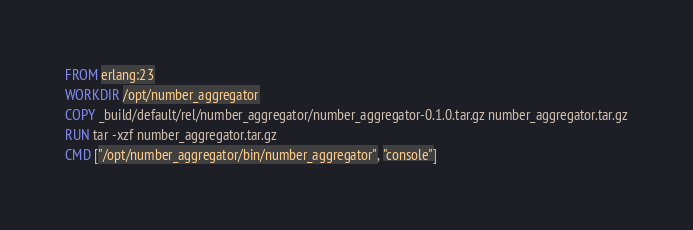Convert code to text. <code><loc_0><loc_0><loc_500><loc_500><_Dockerfile_>FROM erlang:23
WORKDIR /opt/number_aggregator
COPY _build/default/rel/number_aggregator/number_aggregator-0.1.0.tar.gz number_aggregator.tar.gz
RUN tar -xzf number_aggregator.tar.gz
CMD ["/opt/number_aggregator/bin/number_aggregator", "console"]
</code> 